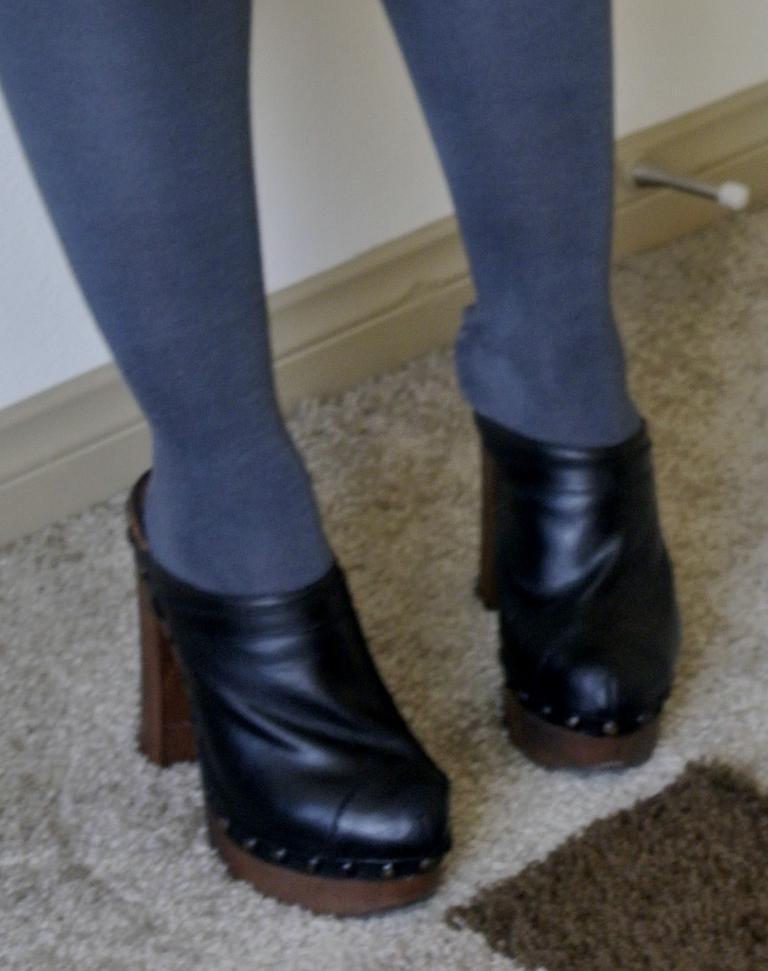Describe this image in one or two sentences. In this image, I can see a person's legs with socks and heels. This looks like a carpet on the floor. Here is the wall. 